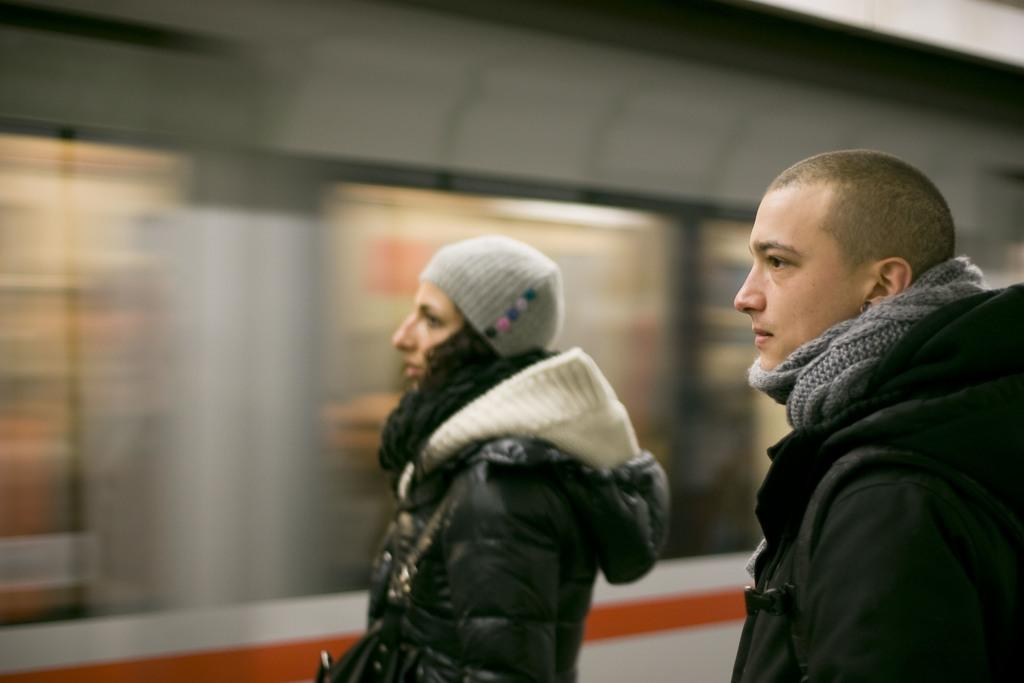How many people are in the image? There are persons in the image, but the exact number is not specified. What are the persons wearing? The persons are wearing clothes. Can you describe the background of the image? The background of the image is blurred. What type of cheese can be seen on the cat's fur in the image? There is no cat or cheese present in the image. 